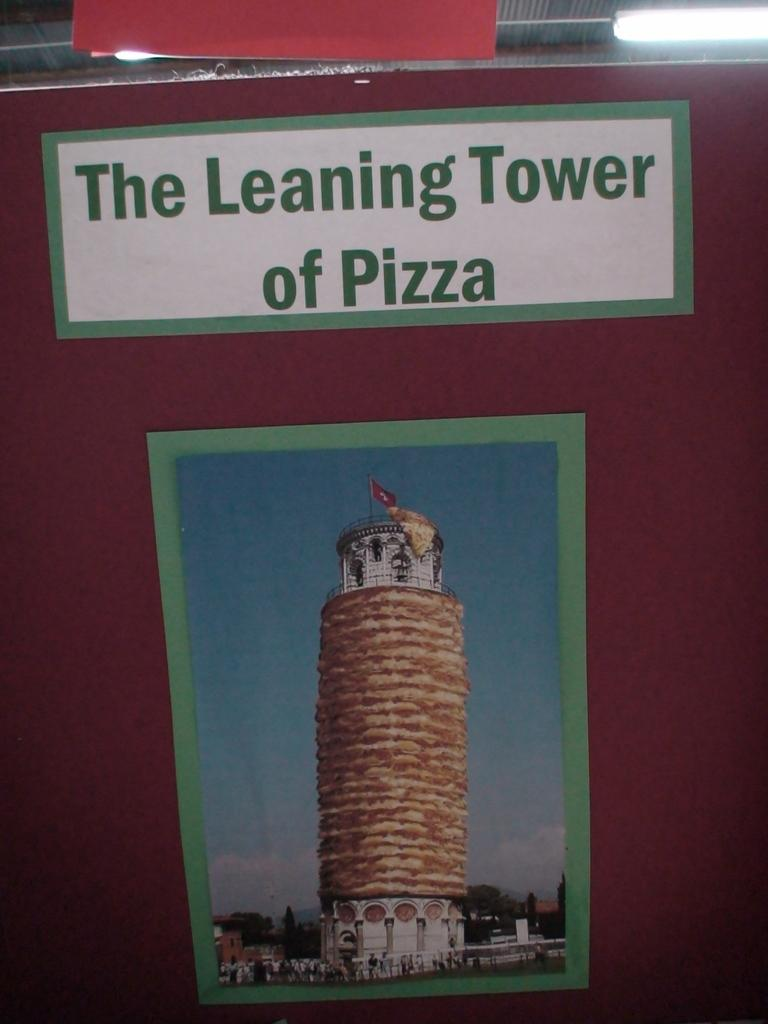Provide a one-sentence caption for the provided image. A poster of the leaning tower of pisa, but made of pizza. 